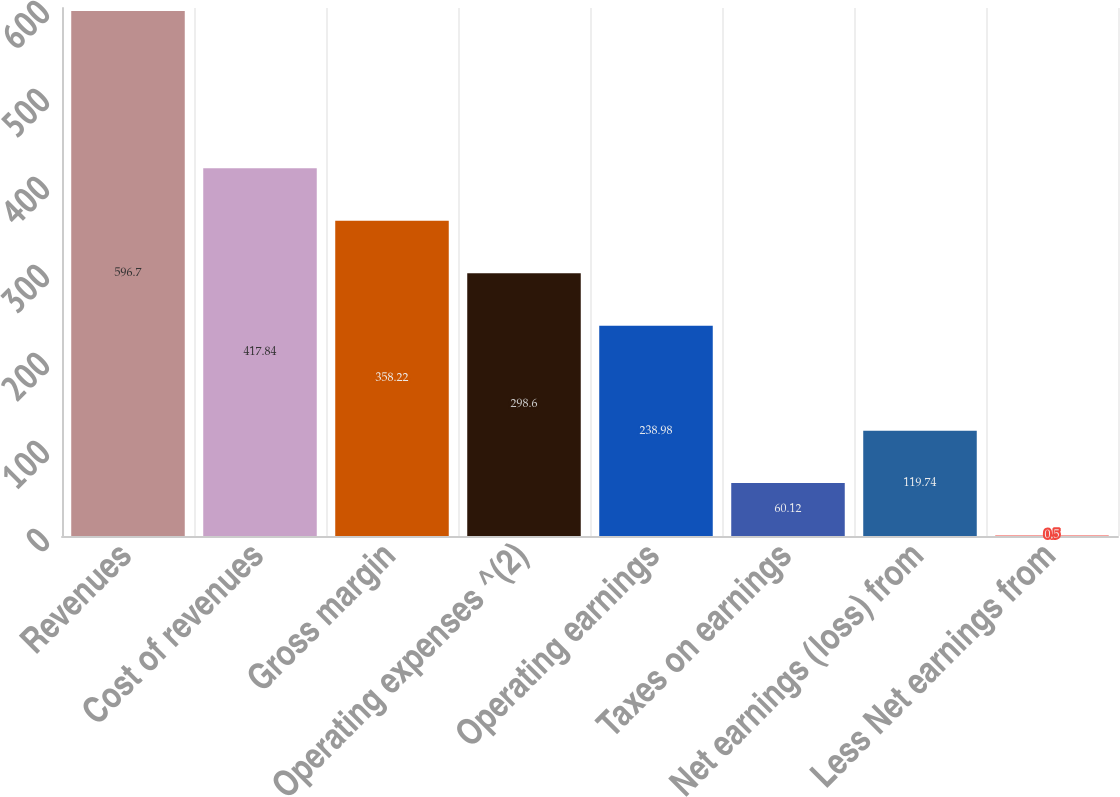Convert chart to OTSL. <chart><loc_0><loc_0><loc_500><loc_500><bar_chart><fcel>Revenues<fcel>Cost of revenues<fcel>Gross margin<fcel>Operating expenses ^(2)<fcel>Operating earnings<fcel>Taxes on earnings<fcel>Net earnings (loss) from<fcel>Less Net earnings from<nl><fcel>596.7<fcel>417.84<fcel>358.22<fcel>298.6<fcel>238.98<fcel>60.12<fcel>119.74<fcel>0.5<nl></chart> 